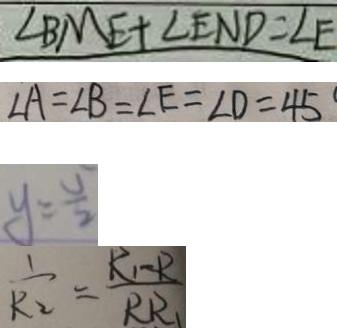Convert formula to latex. <formula><loc_0><loc_0><loc_500><loc_500>\angle B M E + \angle E N D = \angle E 
 \angle A = \angle B = \angle E = \angle D = 4 5 ^ { \circ } 
 y = \frac { v } { 2 } 
 \frac { 1 } { R _ { 2 } } = \frac { R _ { 1 } R } { R R _ { 1 } }</formula> 